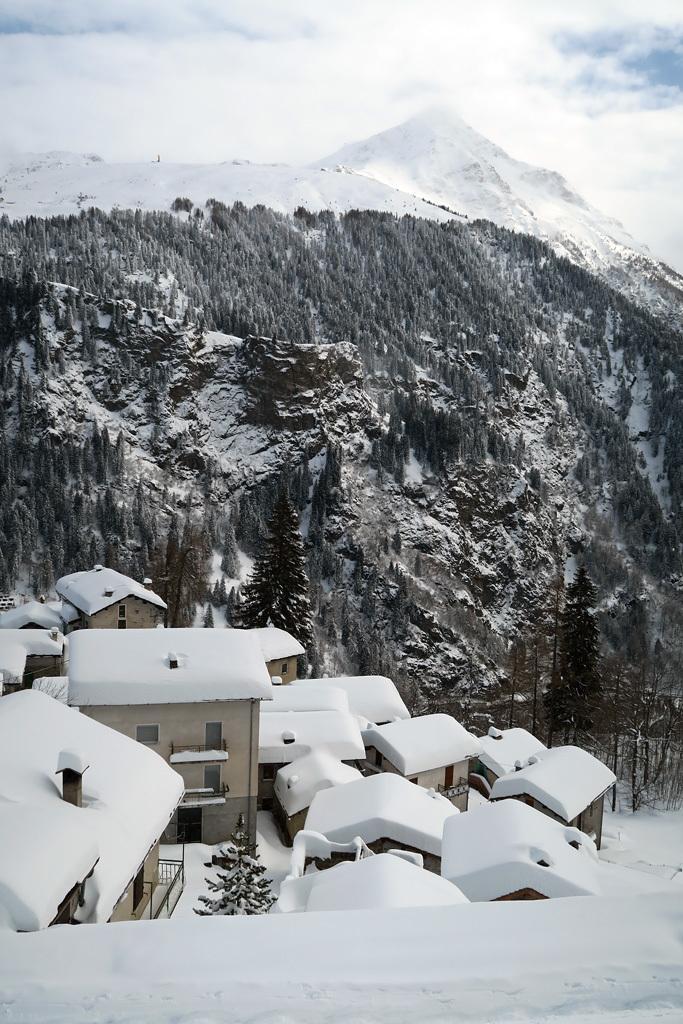Could you give a brief overview of what you see in this image? This image is taken outdoors. At the bottom of the image there is snow on the ground. At the top of the image there is the sky with clouds. In the background there are many hills. There are many trees covered with snow. In the middle of the image there are a few houses covered with snow. 